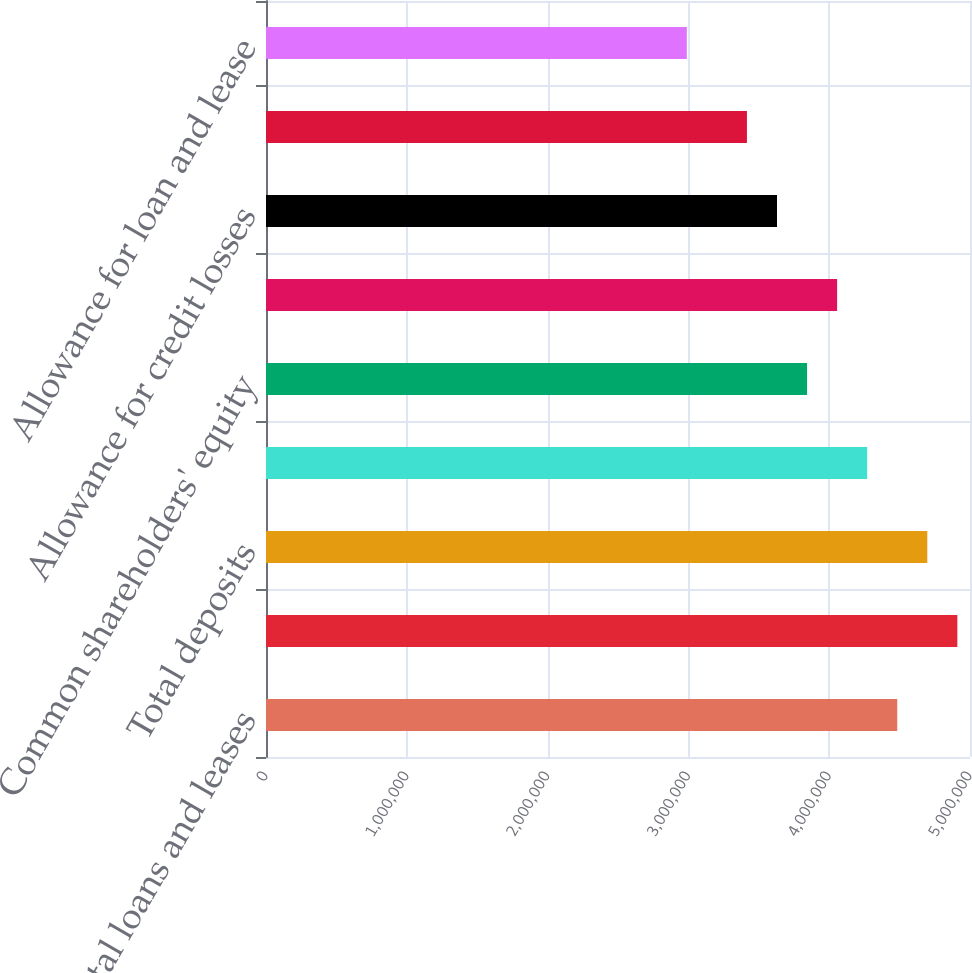Convert chart. <chart><loc_0><loc_0><loc_500><loc_500><bar_chart><fcel>Total loans and leases<fcel>Total assets<fcel>Total deposits<fcel>Long-term debt<fcel>Common shareholders' equity<fcel>Total shareholders' equity<fcel>Allowance for credit losses<fcel>Nonperforming loans leases and<fcel>Allowance for loan and lease<nl><fcel>4.48324e+06<fcel>4.91021e+06<fcel>4.69672e+06<fcel>4.26975e+06<fcel>3.84277e+06<fcel>4.05626e+06<fcel>3.62929e+06<fcel>3.4158e+06<fcel>2.98882e+06<nl></chart> 